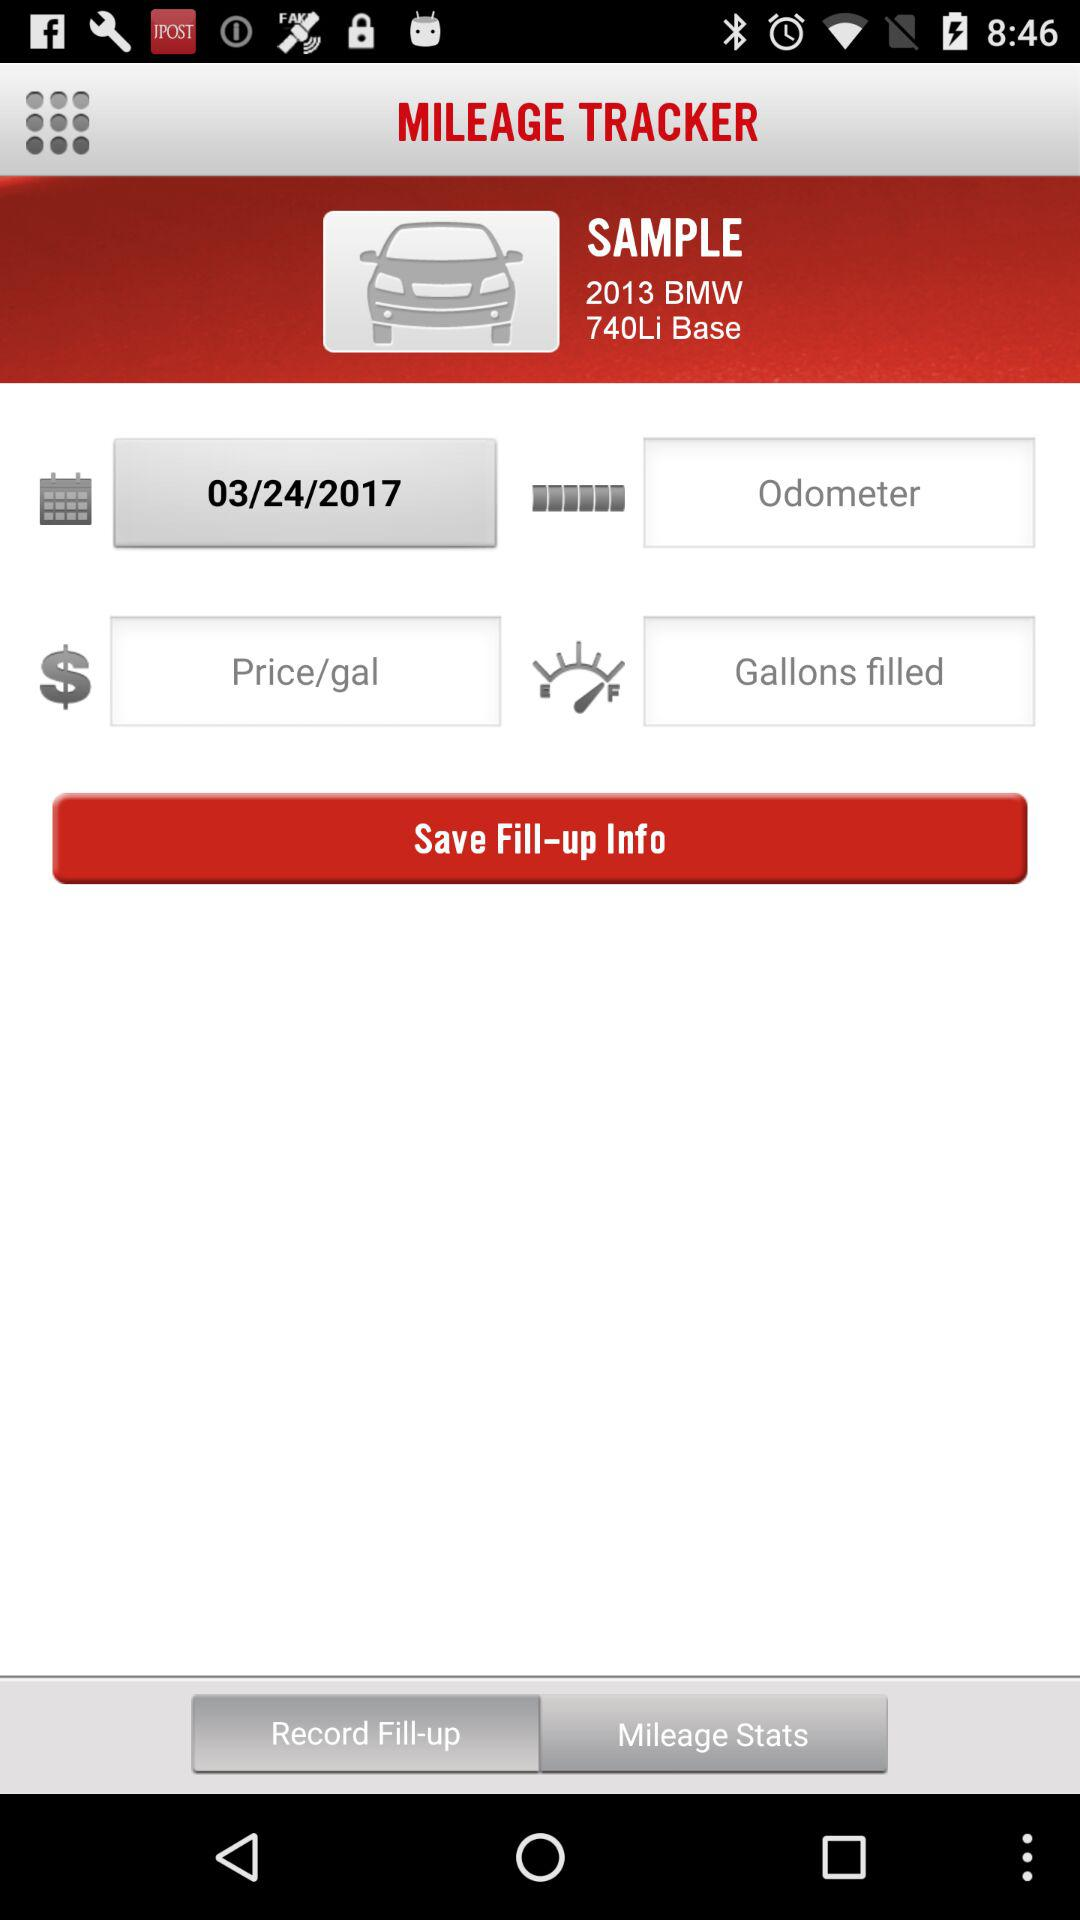What is the mentioned date? The mentioned date is March 24, 2017. 